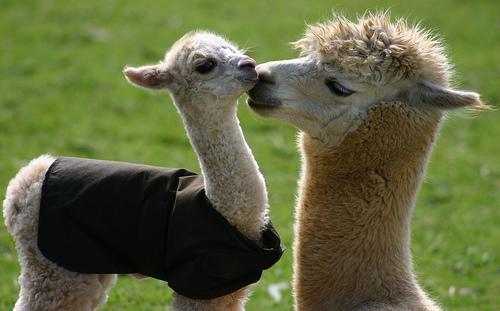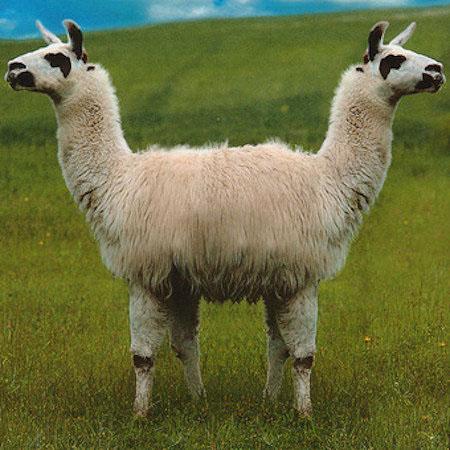The first image is the image on the left, the second image is the image on the right. For the images displayed, is the sentence "Two white llamas of similar size are in a kissing pose in the right image." factually correct? Answer yes or no. No. The first image is the image on the left, the second image is the image on the right. For the images shown, is this caption "The left and right image contains the same number of alpacas." true? Answer yes or no. Yes. 